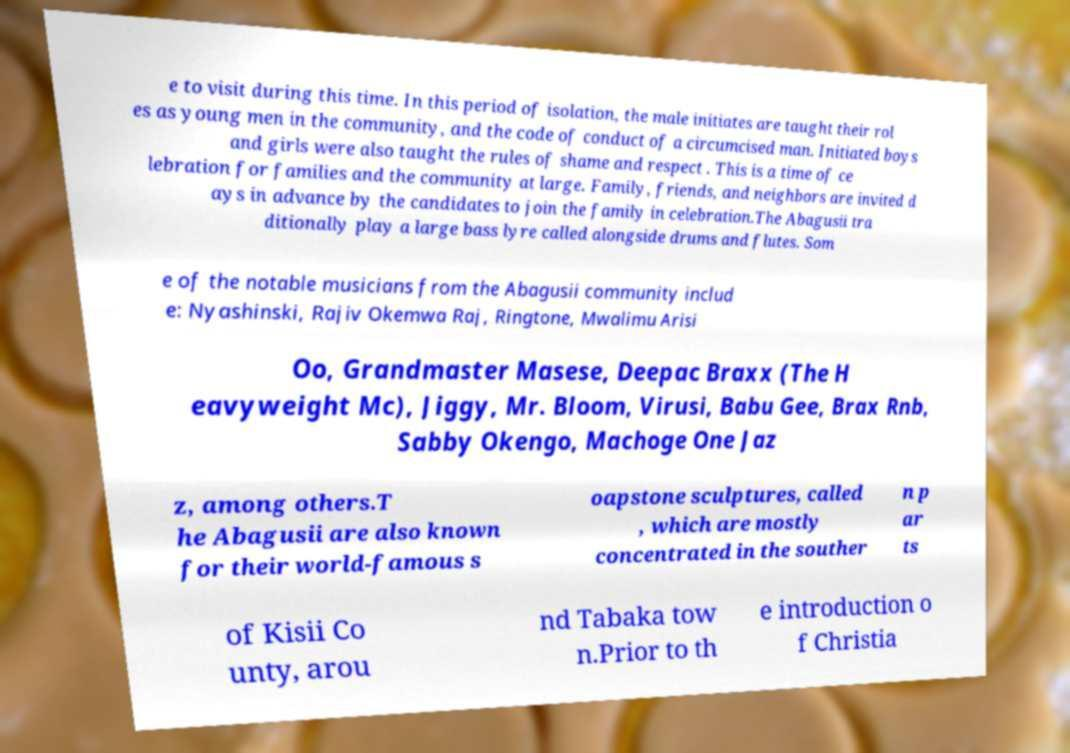Can you read and provide the text displayed in the image?This photo seems to have some interesting text. Can you extract and type it out for me? e to visit during this time. In this period of isolation, the male initiates are taught their rol es as young men in the community, and the code of conduct of a circumcised man. Initiated boys and girls were also taught the rules of shame and respect . This is a time of ce lebration for families and the community at large. Family, friends, and neighbors are invited d ays in advance by the candidates to join the family in celebration.The Abagusii tra ditionally play a large bass lyre called alongside drums and flutes. Som e of the notable musicians from the Abagusii community includ e: Nyashinski, Rajiv Okemwa Raj, Ringtone, Mwalimu Arisi Oo, Grandmaster Masese, Deepac Braxx (The H eavyweight Mc), Jiggy, Mr. Bloom, Virusi, Babu Gee, Brax Rnb, Sabby Okengo, Machoge One Jaz z, among others.T he Abagusii are also known for their world-famous s oapstone sculptures, called , which are mostly concentrated in the souther n p ar ts of Kisii Co unty, arou nd Tabaka tow n.Prior to th e introduction o f Christia 